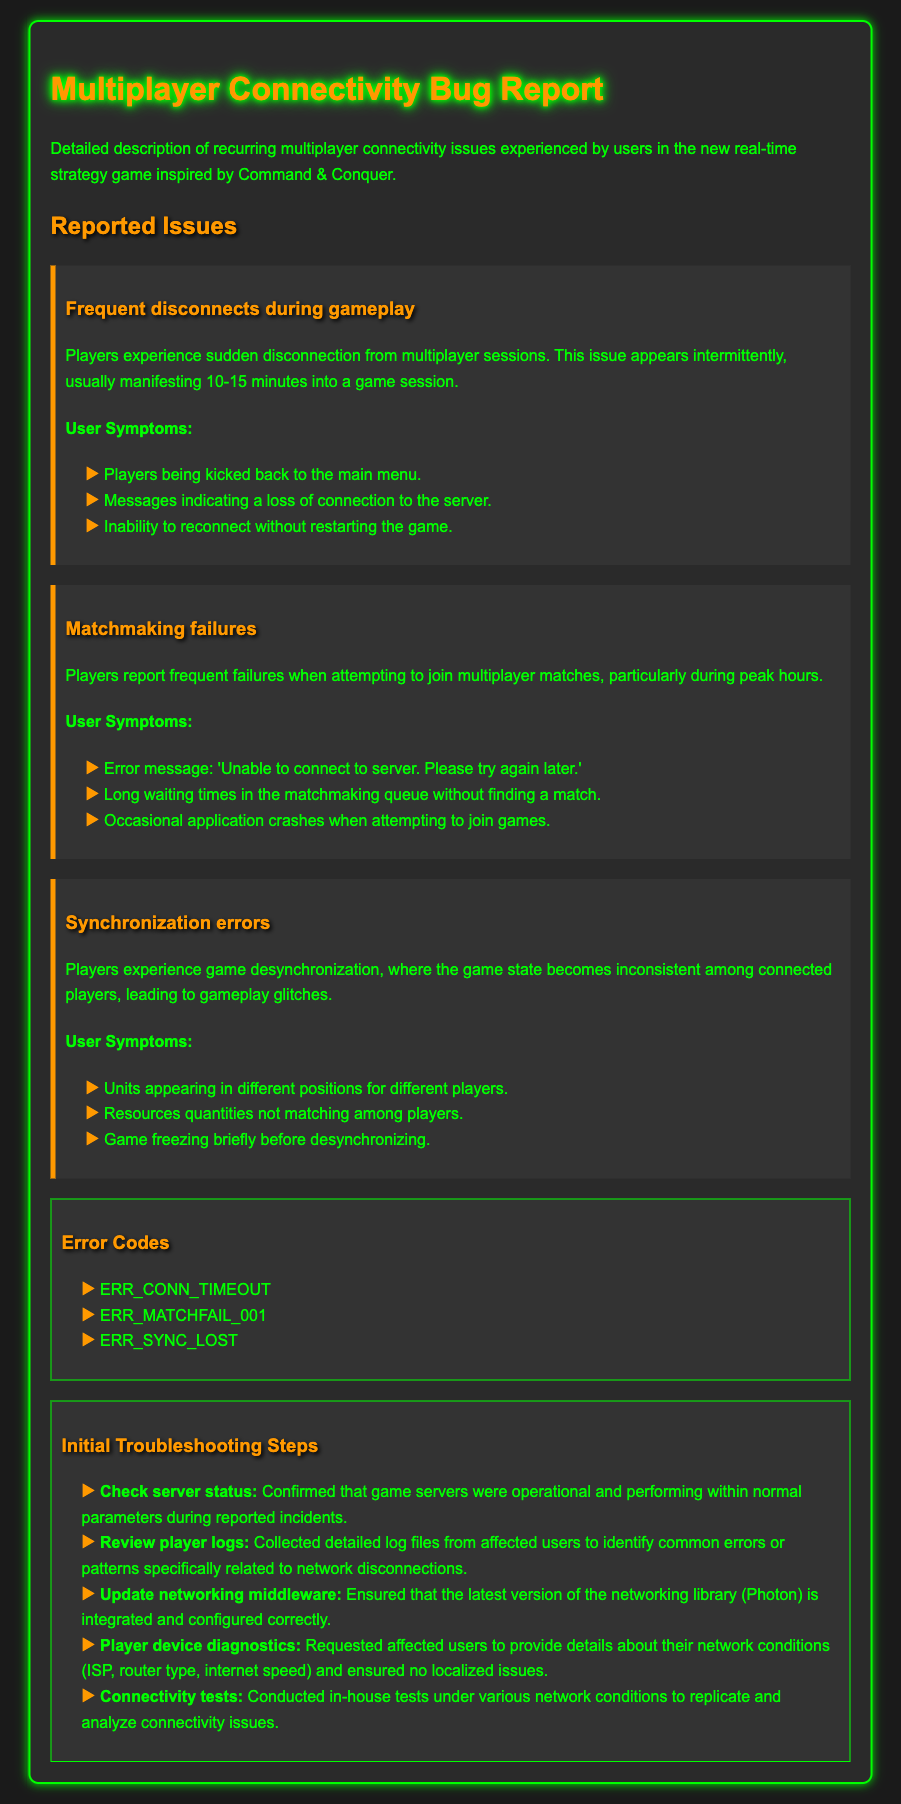What is the title of the document? The title of the document is stated in the header of the rendered document.
Answer: Multiplayer Connectivity Bug Report How many reported issues are detailed in the document? The document describes three distinct issues under the Reported Issues section.
Answer: Three What is the first error code listed in the document? The error codes are listed in a specific section, with the first one being the first item in the list.
Answer: ERR_CONN_TIMEOUT What user symptom is associated with frequent disconnects? User symptoms are detailed under each issue, and one symptom for disconnects is specifically mentioned.
Answer: Players being kicked back to the main menu Which networking library is mentioned in the initial troubleshooting steps? The document specifies a particular networking solution that has been updated and integrated in troubleshooting.
Answer: Photon What is the time frame in which players experience frequent disconnects? The specific time period for experiencing disconnects is identified in the problem description.
Answer: 10-15 minutes What specific action was taken to understand player network conditions? The document outlines an action taken regarding player feedback to ascertain network issues.
Answer: Requested affected users to provide details about their network conditions In what section can you find information about application crashes? Specific user symptoms of matchmaking failures include application crashes, which are detailed in a section.
Answer: Matchmaking failures What color is the background of the main container in the document? The background color of the main container is specified in the CSS style embedded in the document.
Answer: #2a2a2a 